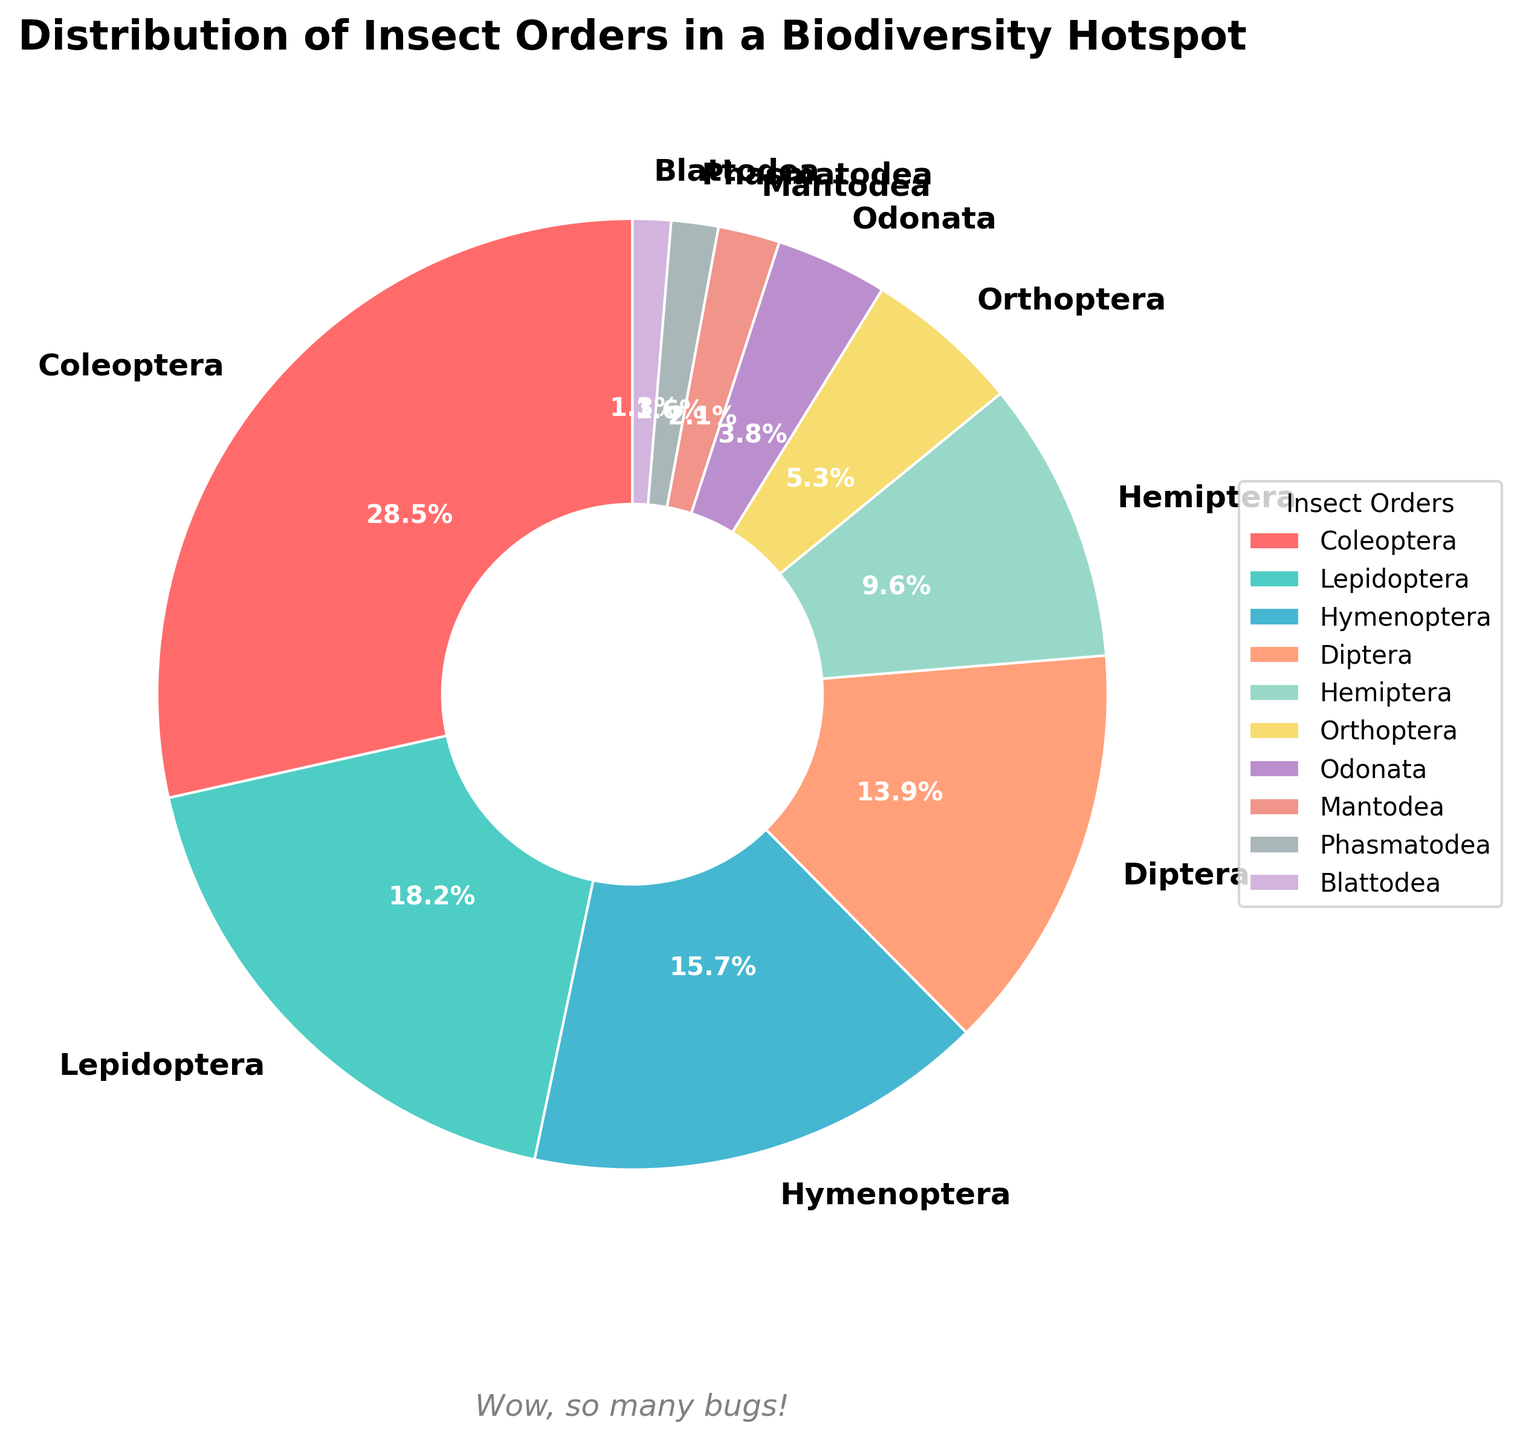What percentage of the orders are represented by Coleoptera and Lepidoptera combined? Add the percentages of Coleoptera (28.5%) and Lepidoptera (18.2%). 28.5 + 18.2 yields 46.7%
Answer: 46.7% Which insect order has the smallest representation in the biodiversity hotspot? Look at the chart for the smallest wedge or slice, which corresponds to Blattodea at 1.3%
Answer: Blattodea How many insect orders have a representation of more than 10%? Identify orders with percentages greater than 10%. These are Coleoptera, Lepidoptera, Hymenoptera, and Diptera—4 insect orders
Answer: 4 Is the percentage of Odonata greater than that of Mantodea? Compare the percentage values: Odonata is 3.8%, Mantodea is 2.1%. 3.8% > 2.1%
Answer: Yes What is the combined percentage of orders with less than 5% representation? Add the percentages of Orthoptera (5.3), Odonata (3.8), Mantodea (2.1), Phasmatodea (1.6), and Blattodea (1.3). 5.3 + 3.8 + 2.1 + 1.6 + 1.3 = 14.1
Answer: 14.1% Which order represents a greater percentage: Diptera or Hymenoptera? Compare the percentages: Diptera is 13.9%, Hymenoptera is 15.7%. 15.7% > 13.9%
Answer: Hymenoptera What is the difference in percentage between the highest and lowest represented orders? Subtract the smallest percentage (Blattodea, 1.3%) from the largest percentage (Coleoptera, 28.5%). 28.5 - 1.3 = 27.2
Answer: 27.2 Do Diptera and Hemiptera together represent more than 20% of the orders? Add the percentages of Diptera (13.9%) and Hemiptera (9.6%). 13.9 + 9.6 = 23.5, which is greater than 20
Answer: Yes 